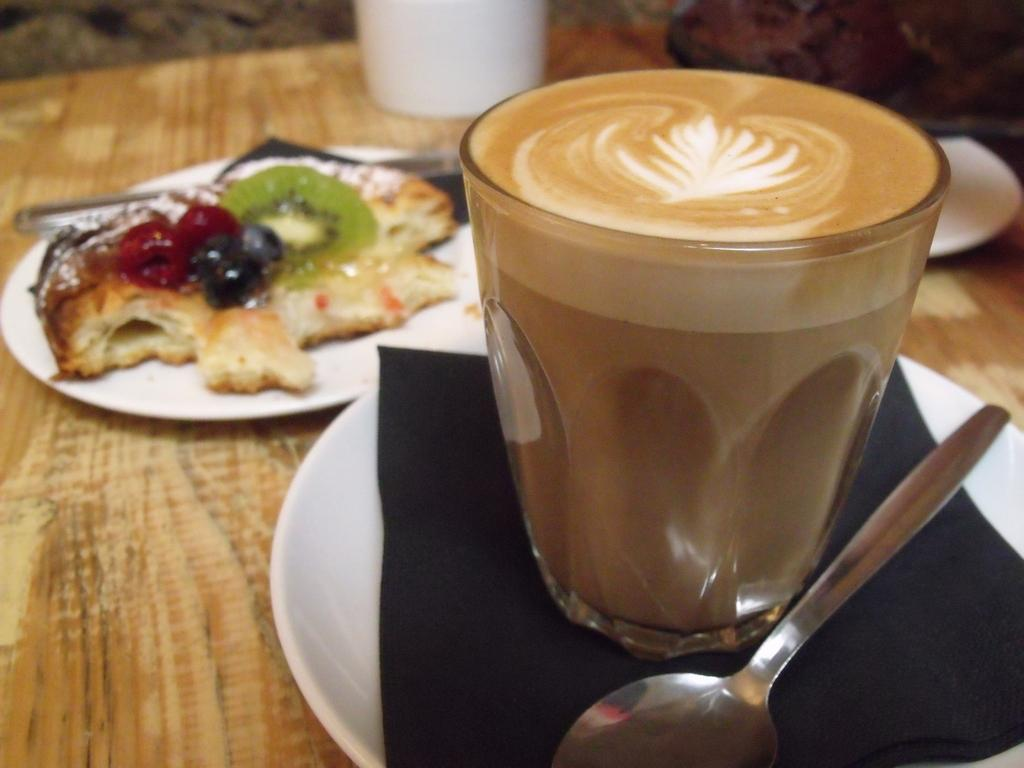What is in the glass that is visible in the image? There is a glass of tea in the image. What utensil is present in the image? There is a spoon in the image. Where is the spoon placed in relation to the glass of tea? The spoon is placed in a saucer. What else can be seen on the table in the image? There is a plate with food in the image. On what surface are all these items placed? All of these items are on a table. What type of noise can be heard coming from the glass of tea in the image? There is no noise coming from the glass of tea in the image. 